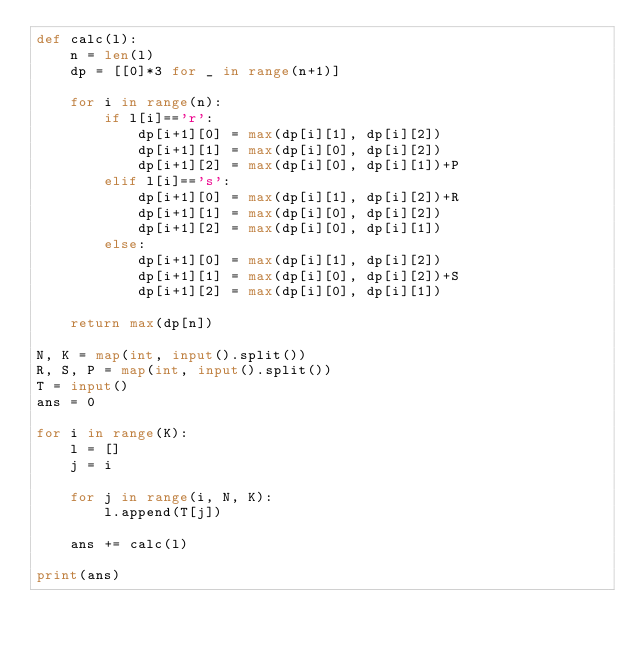<code> <loc_0><loc_0><loc_500><loc_500><_Python_>def calc(l):
    n = len(l)
    dp = [[0]*3 for _ in range(n+1)]
    
    for i in range(n):
        if l[i]=='r':
            dp[i+1][0] = max(dp[i][1], dp[i][2])
            dp[i+1][1] = max(dp[i][0], dp[i][2])
            dp[i+1][2] = max(dp[i][0], dp[i][1])+P
        elif l[i]=='s':
            dp[i+1][0] = max(dp[i][1], dp[i][2])+R
            dp[i+1][1] = max(dp[i][0], dp[i][2])
            dp[i+1][2] = max(dp[i][0], dp[i][1])
        else:
            dp[i+1][0] = max(dp[i][1], dp[i][2])
            dp[i+1][1] = max(dp[i][0], dp[i][2])+S
            dp[i+1][2] = max(dp[i][0], dp[i][1])
    
    return max(dp[n])

N, K = map(int, input().split())
R, S, P = map(int, input().split())
T = input()
ans = 0

for i in range(K):
    l = []
    j = i
    
    for j in range(i, N, K):
        l.append(T[j])
    
    ans += calc(l)

print(ans)</code> 